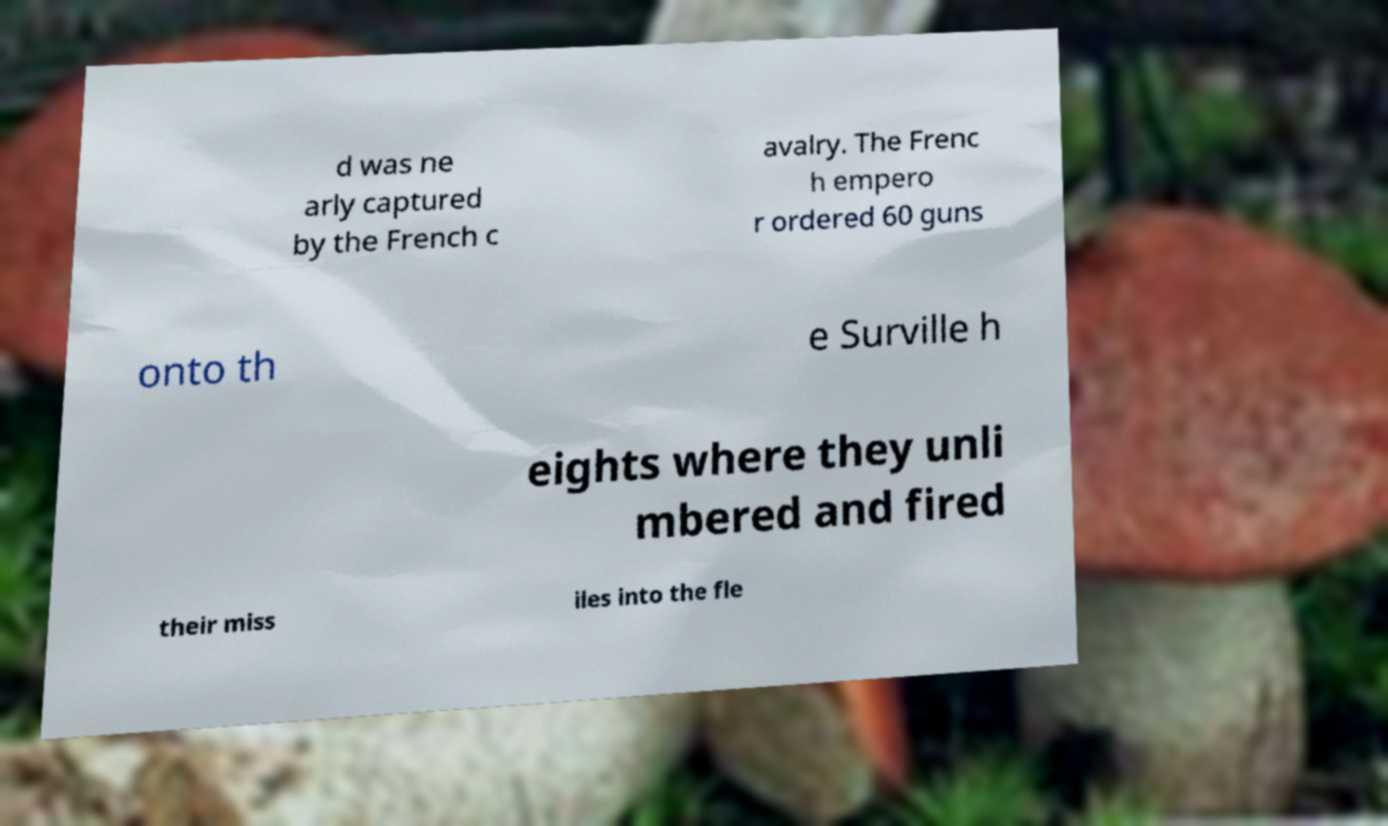For documentation purposes, I need the text within this image transcribed. Could you provide that? d was ne arly captured by the French c avalry. The Frenc h empero r ordered 60 guns onto th e Surville h eights where they unli mbered and fired their miss iles into the fle 